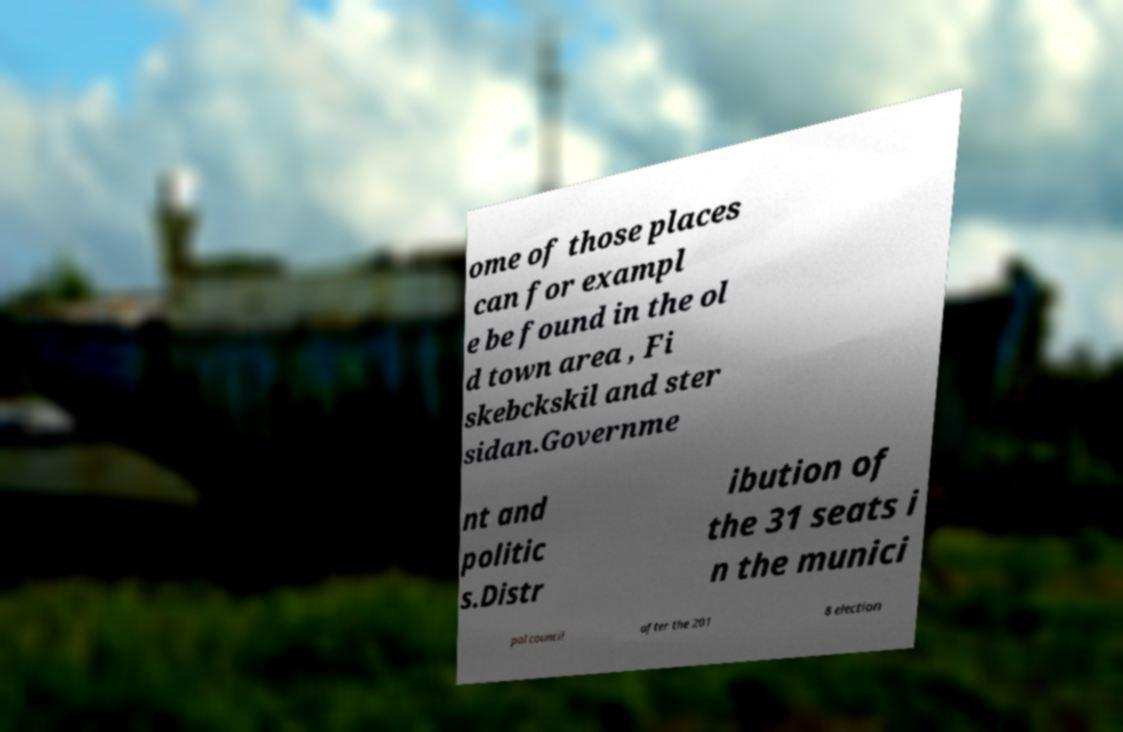Please read and relay the text visible in this image. What does it say? ome of those places can for exampl e be found in the ol d town area , Fi skebckskil and ster sidan.Governme nt and politic s.Distr ibution of the 31 seats i n the munici pal council after the 201 8 election 